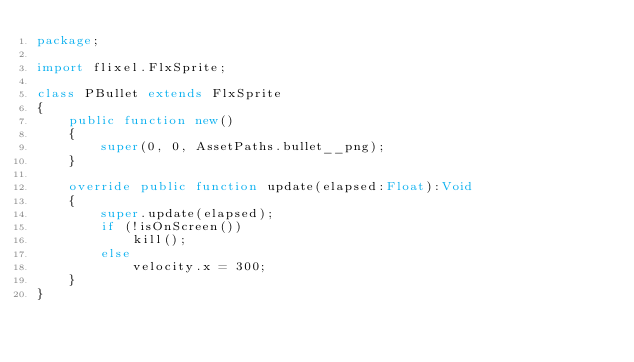Convert code to text. <code><loc_0><loc_0><loc_500><loc_500><_Haxe_>package;

import flixel.FlxSprite;

class PBullet extends FlxSprite
{
	public function new() 
	{
		super(0, 0, AssetPaths.bullet__png);
	}
	
	override public function update(elapsed:Float):Void 
	{
		super.update(elapsed);
		if (!isOnScreen())
			kill();
		else
			velocity.x = 300;
	}
}</code> 